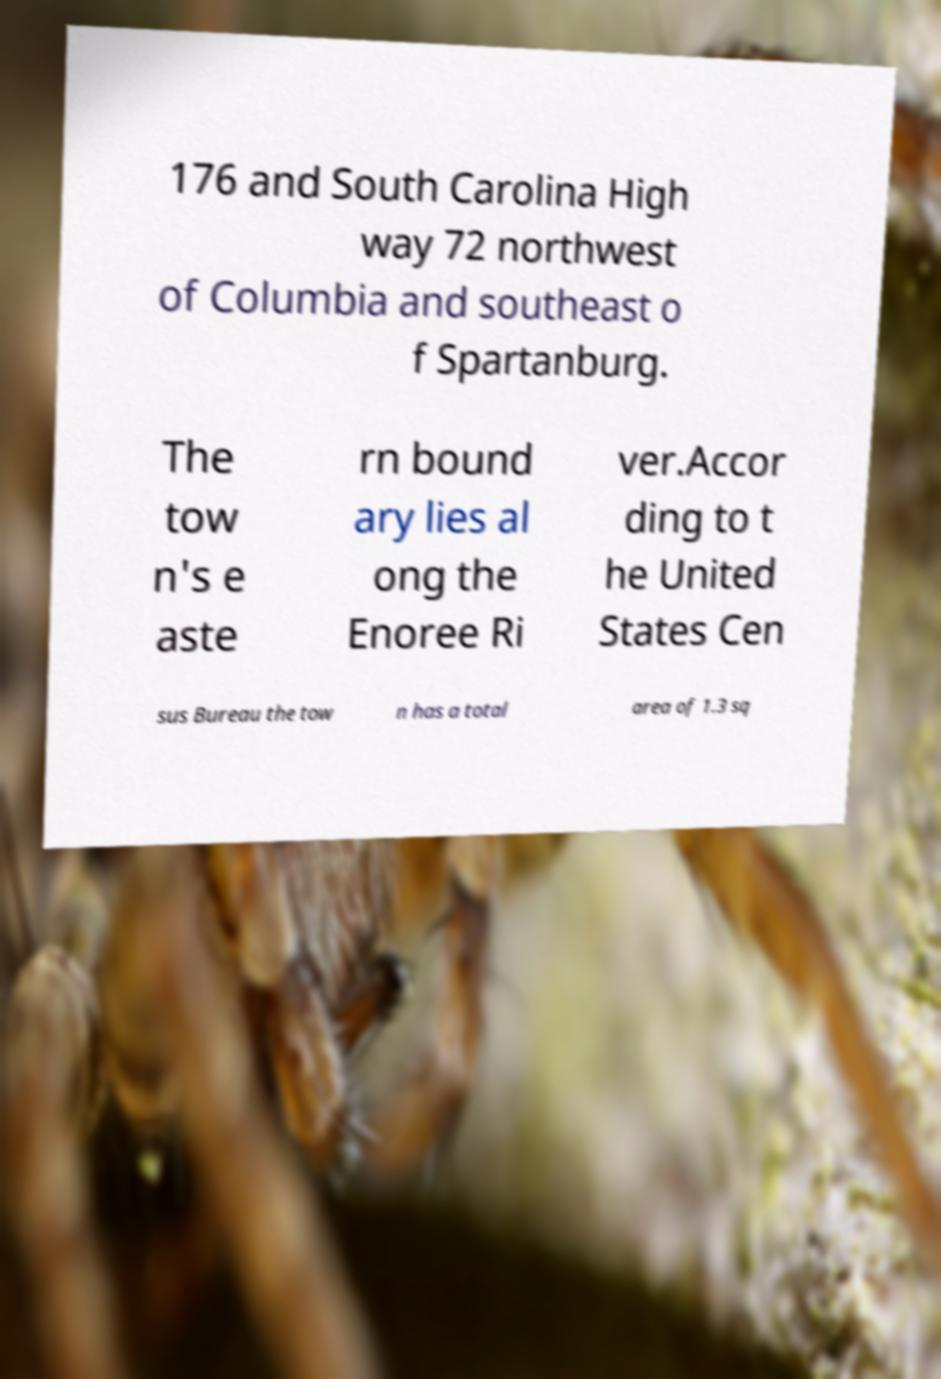Could you assist in decoding the text presented in this image and type it out clearly? 176 and South Carolina High way 72 northwest of Columbia and southeast o f Spartanburg. The tow n's e aste rn bound ary lies al ong the Enoree Ri ver.Accor ding to t he United States Cen sus Bureau the tow n has a total area of 1.3 sq 